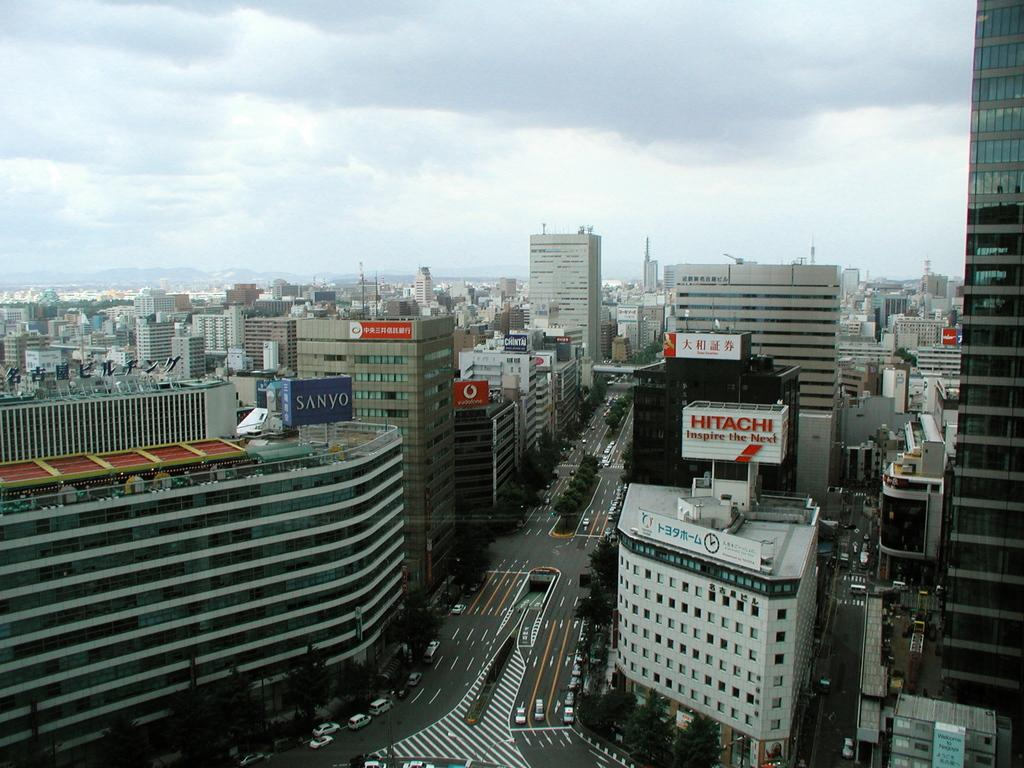What is located in the center of the image? There are buildings in the center of the image. What else can be seen in the image besides the buildings? There is a road in the image, and cars are present on the road. What is visible at the top of the image? The sky is visible at the top of the image. How does the wall contribute to the quiet atmosphere in the image? There is no wall present in the image, and the image does not depict a quiet atmosphere. 